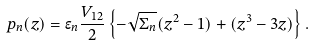<formula> <loc_0><loc_0><loc_500><loc_500>p _ { n } ( z ) = \epsilon _ { n } \frac { V _ { 1 2 } } { 2 } \left \{ - \sqrt { \Sigma _ { n } } ( z ^ { 2 } - 1 ) + ( z ^ { 3 } - 3 z ) \right \} .</formula> 